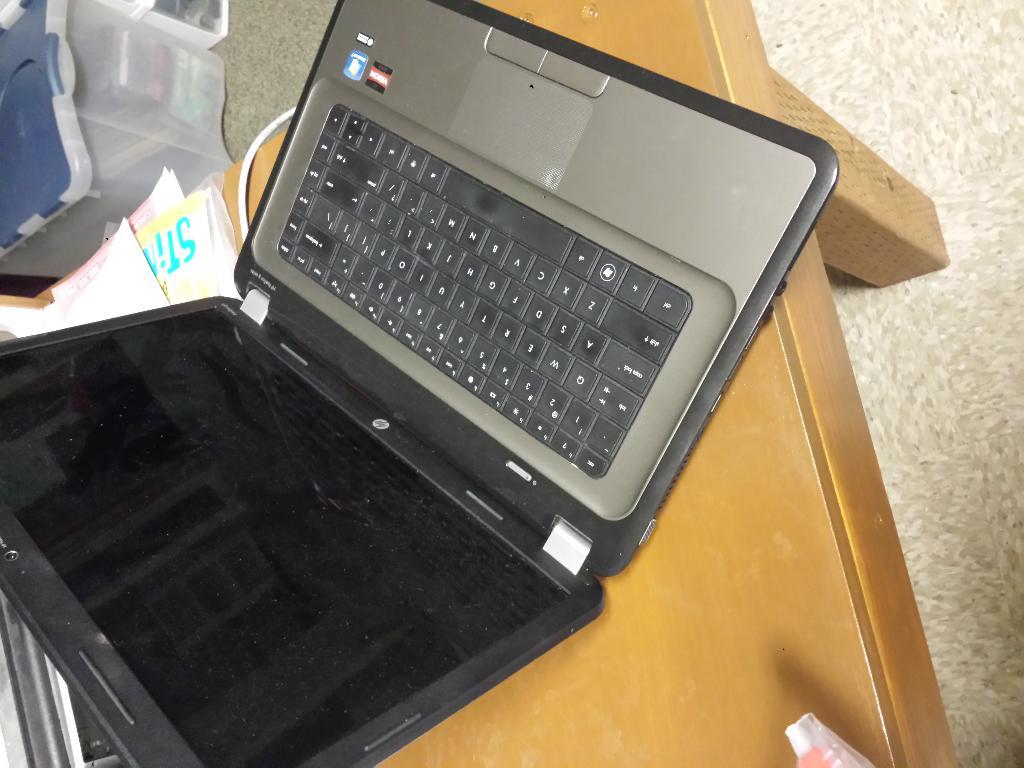What brand of laptop is this?
Offer a very short reply. Hp. 